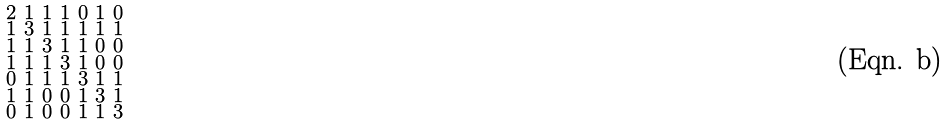Convert formula to latex. <formula><loc_0><loc_0><loc_500><loc_500>\begin{smallmatrix} 2 & 1 & 1 & 1 & 0 & 1 & 0 \\ 1 & 3 & 1 & 1 & 1 & 1 & 1 \\ 1 & 1 & 3 & 1 & 1 & 0 & 0 \\ 1 & 1 & 1 & 3 & 1 & 0 & 0 \\ 0 & 1 & 1 & 1 & 3 & 1 & 1 \\ 1 & 1 & 0 & 0 & 1 & 3 & 1 \\ 0 & 1 & 0 & 0 & 1 & 1 & 3 \end{smallmatrix}</formula> 